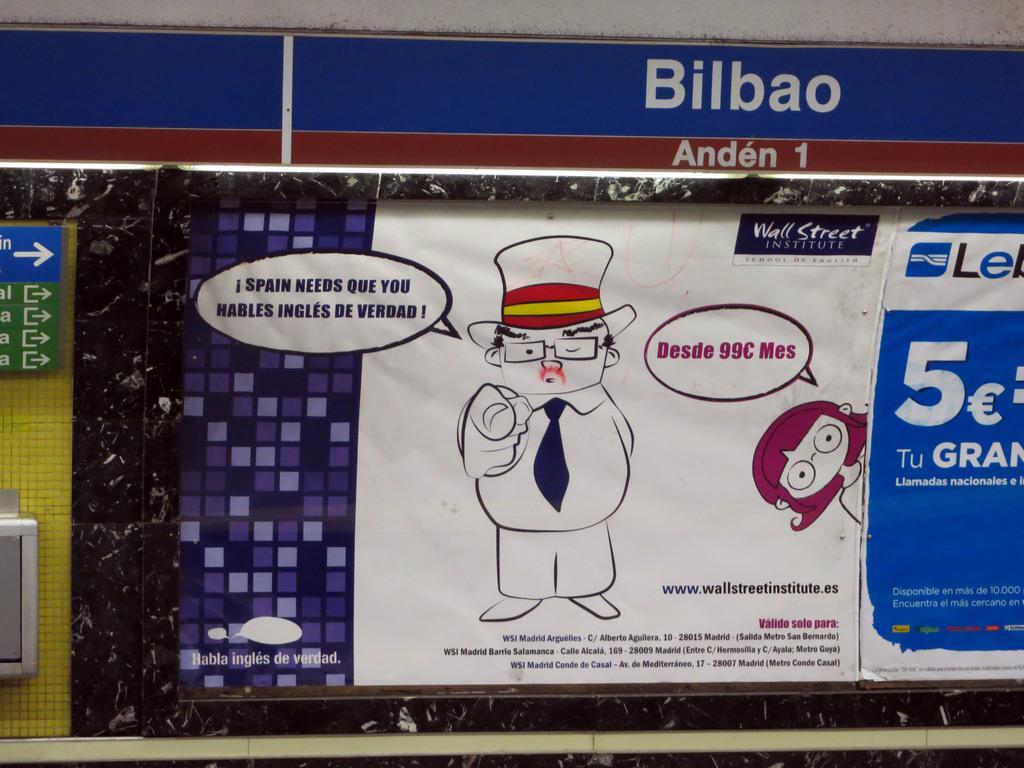Describe this image in one or two sentences. In this picture I can see boards and a poster. There are images, words and numbers on the poster. 